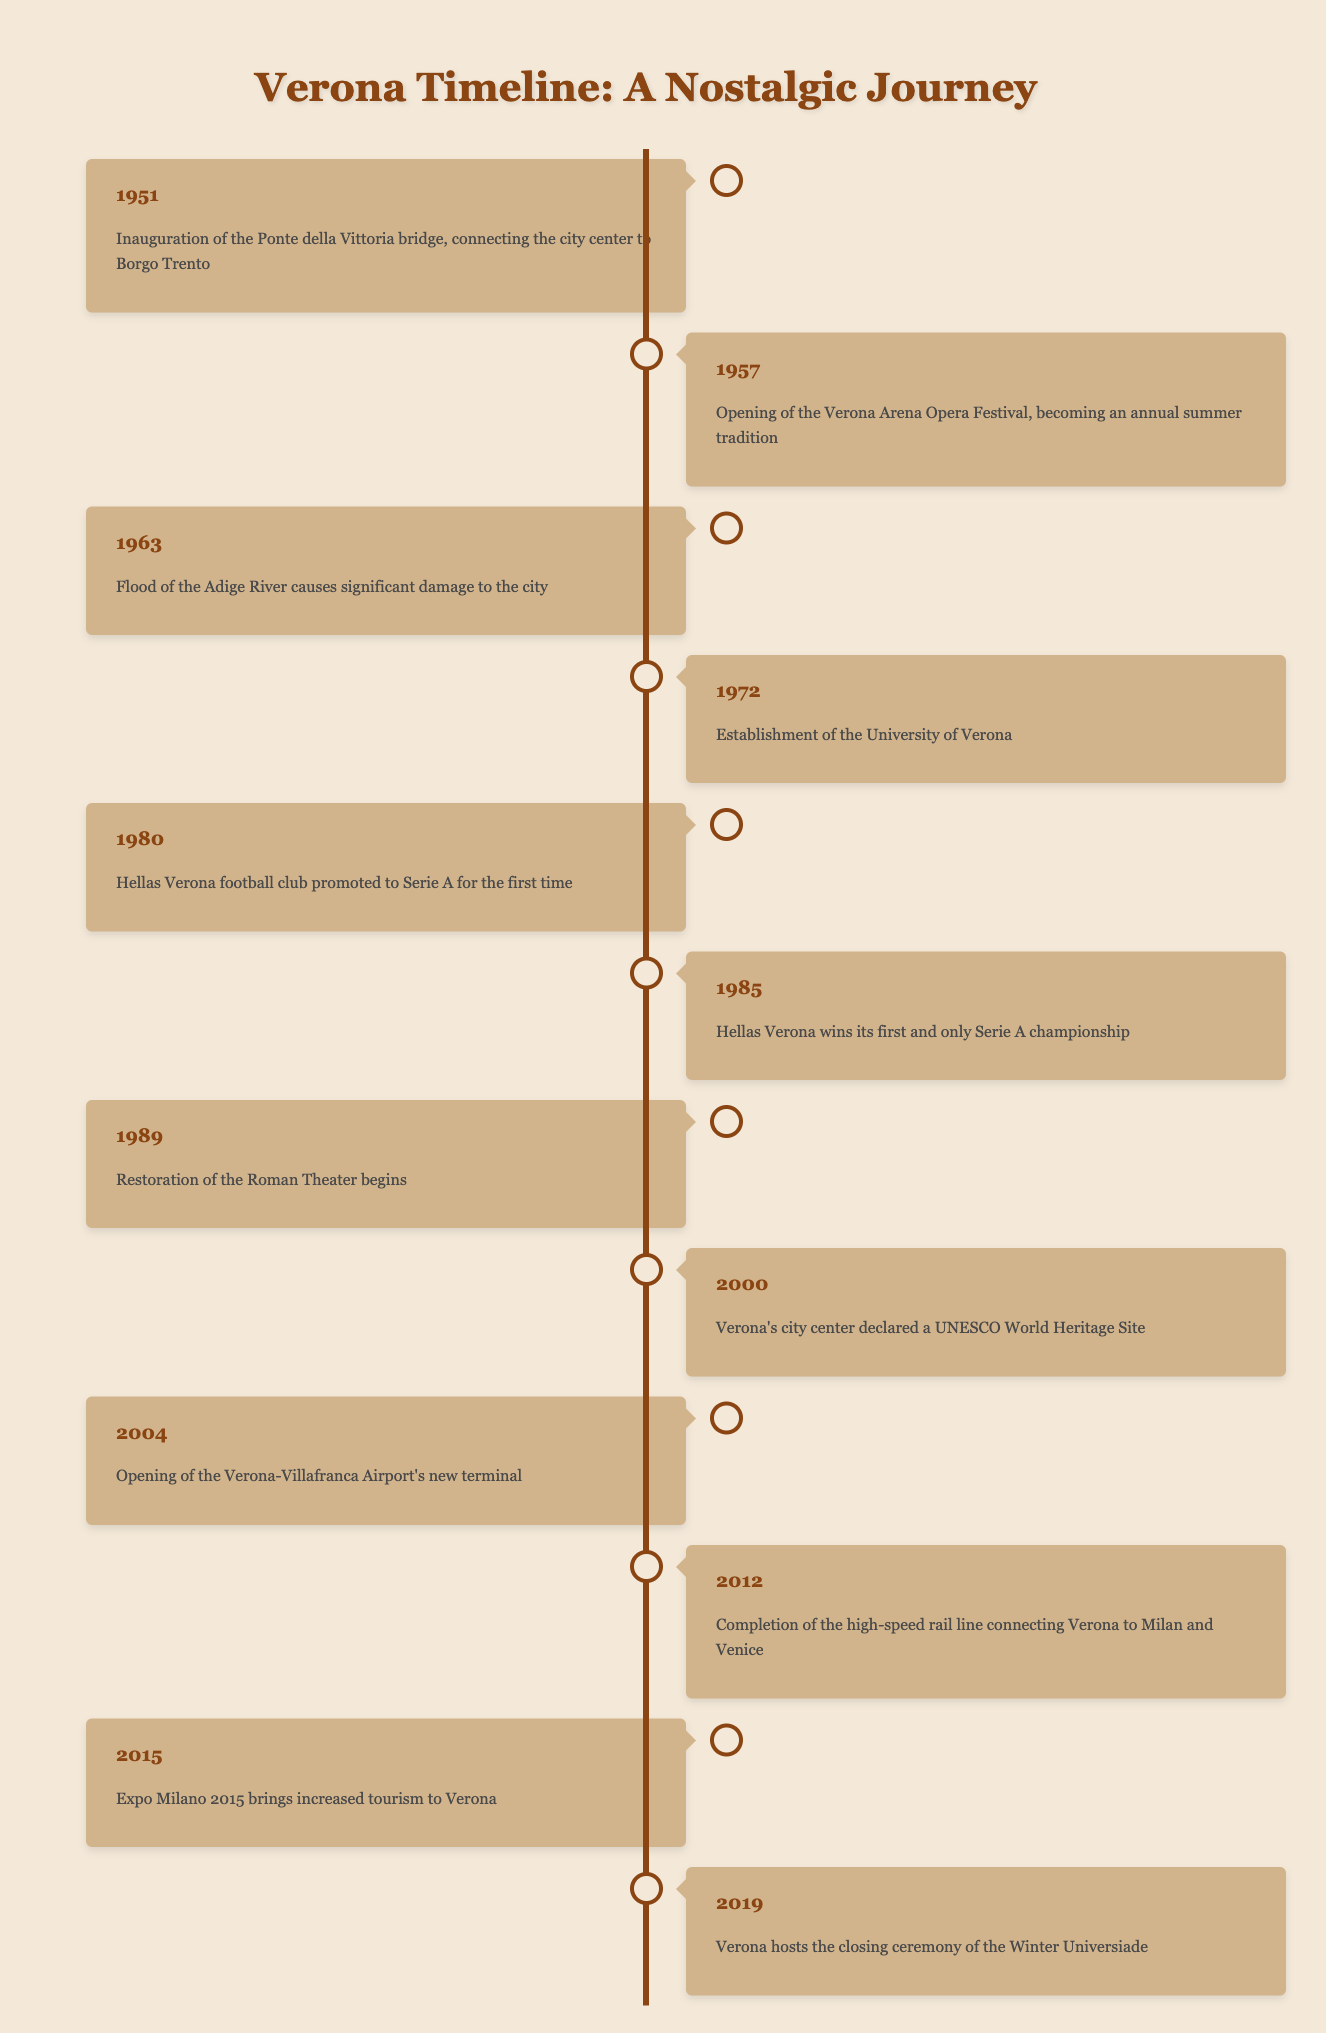What significant event happened in Verona in 1951? The table indicates that in 1951, the Ponte della Vittoria bridge was inaugurated, which connected the city center to Borgo Trento.
Answer: Inauguration of the Ponte della Vittoria bridge How many times did Hellas Verona football club win the Serie A championship? According to the table, Hellas Verona won the Serie A championship once, which is recorded in 1985.
Answer: Once What year did the flood of the Adige River occur in Verona? The table shows that the flood of the Adige River, which caused significant damage to the city, happened in 1963.
Answer: 1963 What is the time span from the establishment of the University of Verona to the declaration of Verona's city center as a UNESCO World Heritage Site? The University of Verona was established in 1972 and the UNESCO declaration occurred in 2000. The time span is 2000 - 1972 = 28 years.
Answer: 28 years Was the Verona Arena Opera Festival started before or after the establishment of the University of Verona? The table reveals that the Verona Arena Opera Festival opened in 1957, which is before the University of Verona was established in 1972.
Answer: Before How many major historical events are listed in the table for the 1980s? The table lists three major events for the 1980s: Hellas Verona's promotion to Serie A in 1980, the championship win in 1985, and the restoration of the Roman Theater beginning in 1989. Therefore, there are three events.
Answer: Three events Did Verona host the Winter Universiade before or after 2012? The table states that Verona hosted the closing ceremony of the Winter Universiade in 2019, which is after 2012.
Answer: After Which year saw the completion of the high-speed rail line connecting Verona to Milan and Venice? The table indicates that the high-speed rail line was completed in 2012.
Answer: 2012 What is the total number of years listed from the earliest event in 1951 to the latest event in 2019? The earliest event in the table is from 1951 and the latest is from 2019. Thus, the total number of years is 2019 - 1951 = 68 years.
Answer: 68 years 